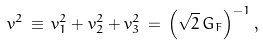Convert formula to latex. <formula><loc_0><loc_0><loc_500><loc_500>v ^ { 2 } \, \equiv \, v _ { 1 } ^ { 2 } + v _ { 2 } ^ { 2 } + v _ { 3 } ^ { 2 } \, = \, \left ( \sqrt { 2 } \, G _ { F } \right ) ^ { - 1 } ,</formula> 